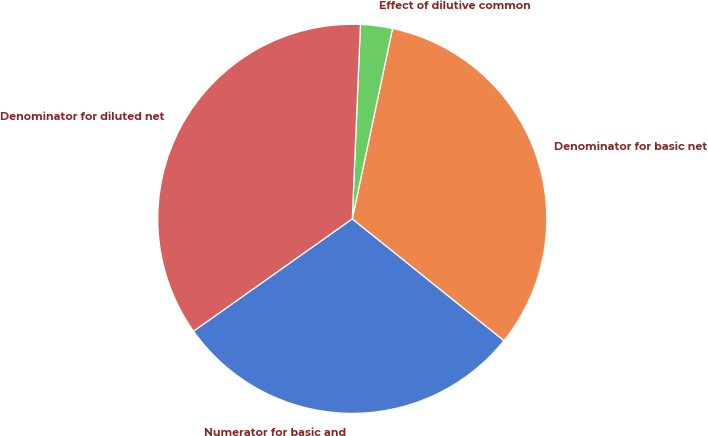Convert chart. <chart><loc_0><loc_0><loc_500><loc_500><pie_chart><fcel>Numerator for basic and<fcel>Denominator for basic net<fcel>Effect of dilutive common<fcel>Denominator for diluted net<nl><fcel>29.43%<fcel>32.45%<fcel>2.65%<fcel>35.47%<nl></chart> 